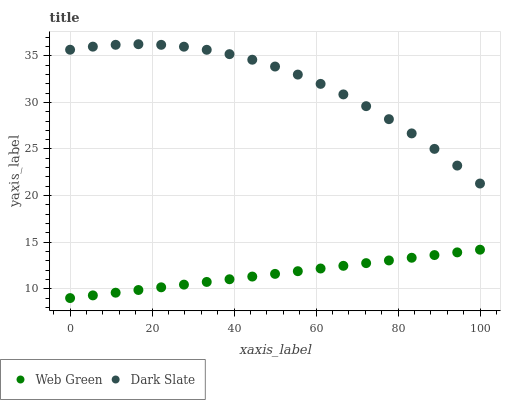Does Web Green have the minimum area under the curve?
Answer yes or no. Yes. Does Dark Slate have the maximum area under the curve?
Answer yes or no. Yes. Does Web Green have the maximum area under the curve?
Answer yes or no. No. Is Web Green the smoothest?
Answer yes or no. Yes. Is Dark Slate the roughest?
Answer yes or no. Yes. Is Web Green the roughest?
Answer yes or no. No. Does Web Green have the lowest value?
Answer yes or no. Yes. Does Dark Slate have the highest value?
Answer yes or no. Yes. Does Web Green have the highest value?
Answer yes or no. No. Is Web Green less than Dark Slate?
Answer yes or no. Yes. Is Dark Slate greater than Web Green?
Answer yes or no. Yes. Does Web Green intersect Dark Slate?
Answer yes or no. No. 